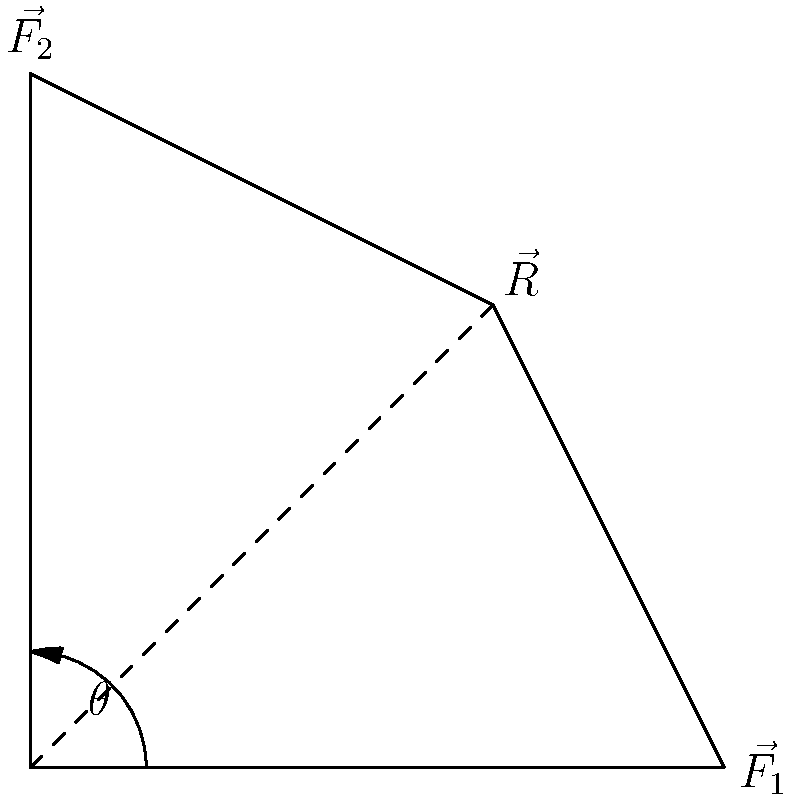In a web-based physics simulation for an open-source project, you need to calculate the resultant vector $\vec{R}$ when combining two force vectors $\vec{F_1}$ and $\vec{F_2}$. Given $\vec{F_1} = 3\hat{i}$ N, $\vec{F_2} = 3\hat{j}$ N, what is the magnitude of the resultant vector $\vec{R}$ and its angle $\theta$ with respect to the positive x-axis? To solve this problem, we'll follow these steps:

1. Identify the components of the vectors:
   $\vec{F_1} = 3\hat{i}$ N (3 units in x-direction)
   $\vec{F_2} = 3\hat{j}$ N (3 units in y-direction)

2. Calculate the resultant vector $\vec{R}$:
   $\vec{R} = \vec{F_1} + \vec{F_2} = 3\hat{i} + 3\hat{j}$ N

3. Calculate the magnitude of $\vec{R}$ using the Pythagorean theorem:
   $|\vec{R}| = \sqrt{(3)^2 + (3)^2} = \sqrt{18} = 3\sqrt{2}$ N

4. Calculate the angle $\theta$ using the arctangent function:
   $\theta = \arctan(\frac{y}{x}) = \arctan(\frac{3}{3}) = \arctan(1) = 45°$

In a web-based simulation, you would use JavaScript's Math object:
Magnitude: `Math.sqrt(3*3 + 3*3)`
Angle: `Math.atan2(3, 3) * (180 / Math.PI)` (converting radians to degrees)
Answer: $|\vec{R}| = 3\sqrt{2}$ N, $\theta = 45°$ 